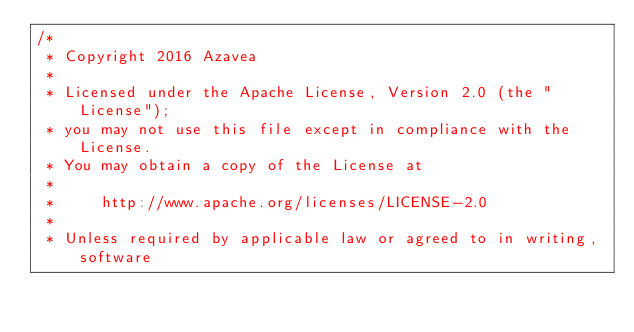Convert code to text. <code><loc_0><loc_0><loc_500><loc_500><_Scala_>/*
 * Copyright 2016 Azavea
 *
 * Licensed under the Apache License, Version 2.0 (the "License");
 * you may not use this file except in compliance with the License.
 * You may obtain a copy of the License at
 *
 *     http://www.apache.org/licenses/LICENSE-2.0
 *
 * Unless required by applicable law or agreed to in writing, software</code> 